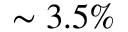<formula> <loc_0><loc_0><loc_500><loc_500>\sim 3 . 5 \%</formula> 